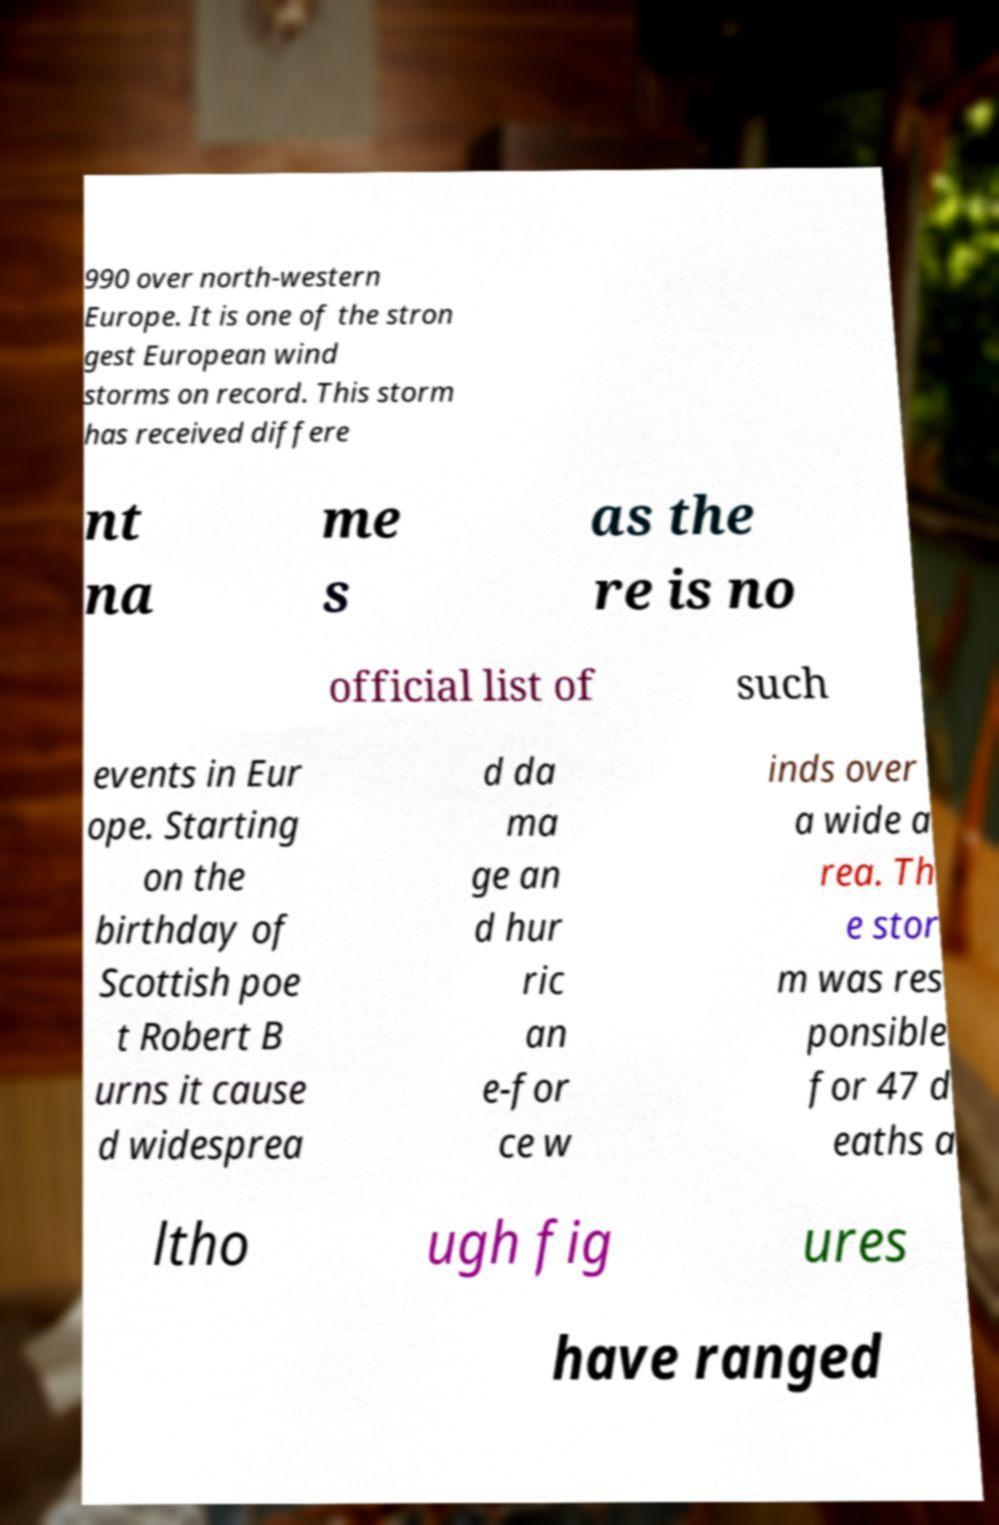Please identify and transcribe the text found in this image. 990 over north-western Europe. It is one of the stron gest European wind storms on record. This storm has received differe nt na me s as the re is no official list of such events in Eur ope. Starting on the birthday of Scottish poe t Robert B urns it cause d widesprea d da ma ge an d hur ric an e-for ce w inds over a wide a rea. Th e stor m was res ponsible for 47 d eaths a ltho ugh fig ures have ranged 